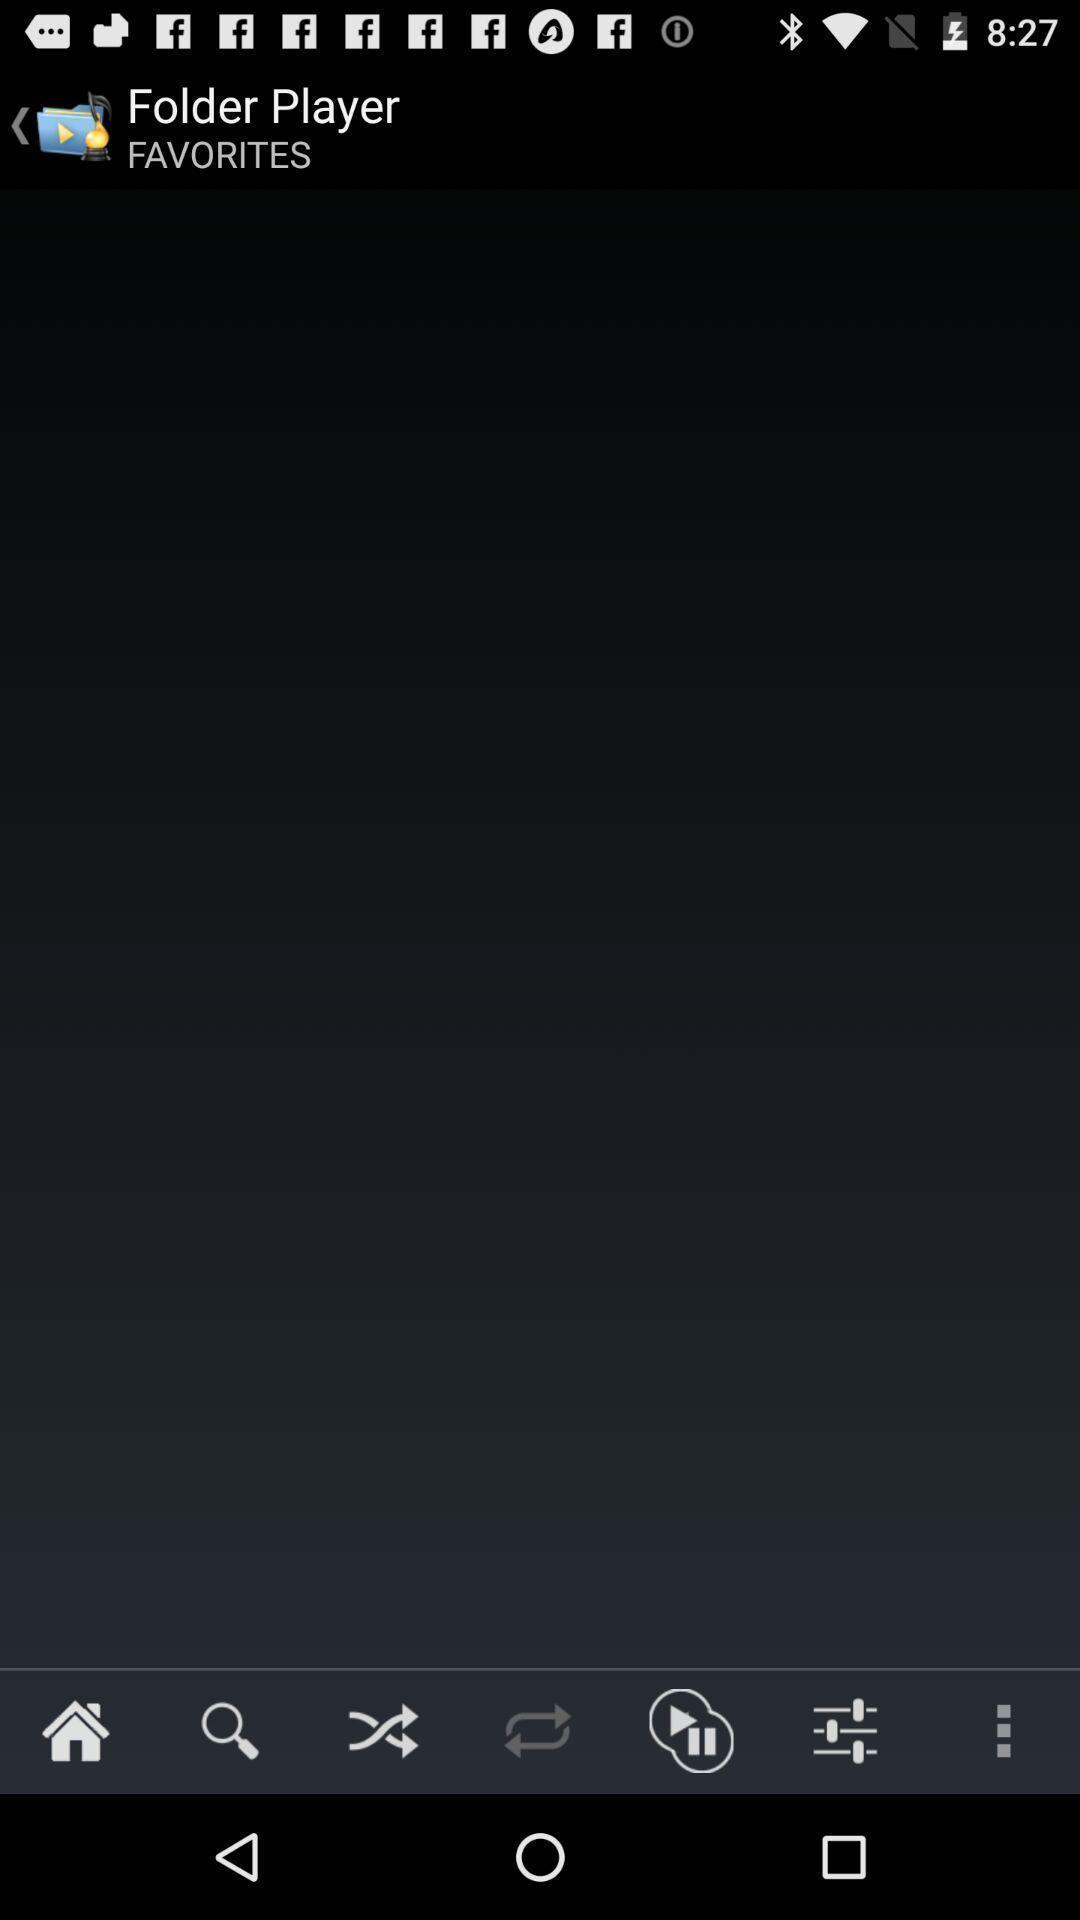Provide a detailed account of this screenshot. Screen displaying a blank page with multiple controls. 